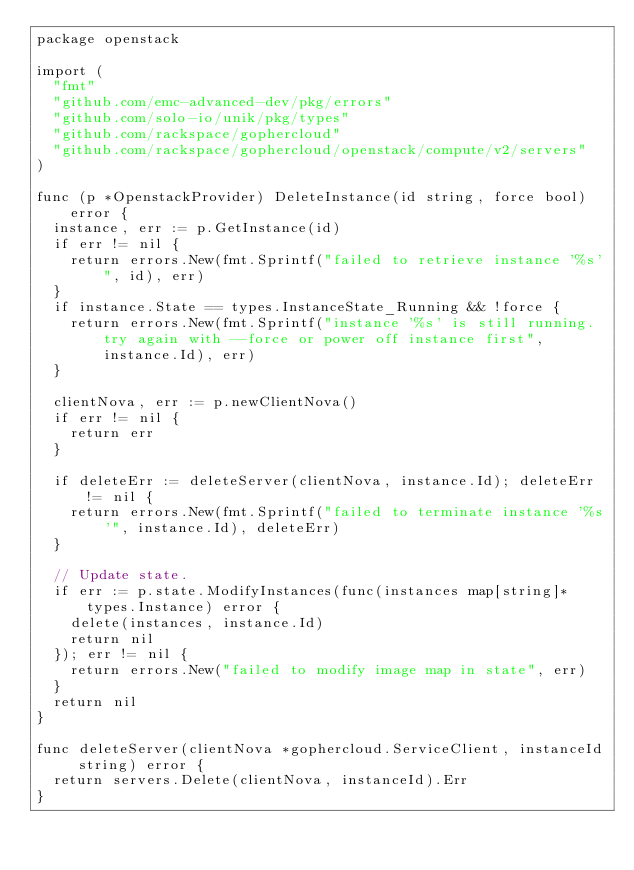Convert code to text. <code><loc_0><loc_0><loc_500><loc_500><_Go_>package openstack

import (
	"fmt"
	"github.com/emc-advanced-dev/pkg/errors"
	"github.com/solo-io/unik/pkg/types"
	"github.com/rackspace/gophercloud"
	"github.com/rackspace/gophercloud/openstack/compute/v2/servers"
)

func (p *OpenstackProvider) DeleteInstance(id string, force bool) error {
	instance, err := p.GetInstance(id)
	if err != nil {
		return errors.New(fmt.Sprintf("failed to retrieve instance '%s'", id), err)
	}
	if instance.State == types.InstanceState_Running && !force {
		return errors.New(fmt.Sprintf("instance '%s' is still running. try again with --force or power off instance first", instance.Id), err)
	}

	clientNova, err := p.newClientNova()
	if err != nil {
		return err
	}

	if deleteErr := deleteServer(clientNova, instance.Id); deleteErr != nil {
		return errors.New(fmt.Sprintf("failed to terminate instance '%s'", instance.Id), deleteErr)
	}

	// Update state.
	if err := p.state.ModifyInstances(func(instances map[string]*types.Instance) error {
		delete(instances, instance.Id)
		return nil
	}); err != nil {
		return errors.New("failed to modify image map in state", err)
	}
	return nil
}

func deleteServer(clientNova *gophercloud.ServiceClient, instanceId string) error {
	return servers.Delete(clientNova, instanceId).Err
}
</code> 